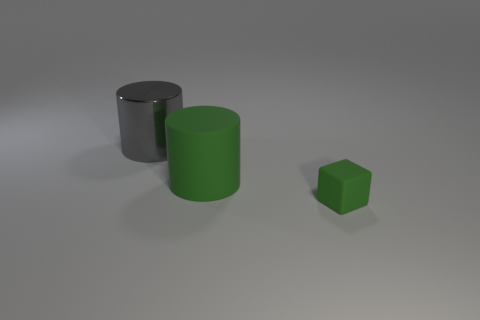Is the tiny rubber object the same color as the rubber cylinder?
Make the answer very short. Yes. There is a cylinder in front of the big gray cylinder; is its size the same as the thing behind the green rubber cylinder?
Your answer should be very brief. Yes. The rubber object that is in front of the large cylinder to the right of the gray cylinder is what color?
Ensure brevity in your answer.  Green. There is a green object that is the same size as the gray cylinder; what is it made of?
Provide a succinct answer. Rubber. How many shiny things are large objects or large gray objects?
Ensure brevity in your answer.  1. What is the color of the thing that is behind the small green cube and in front of the shiny object?
Keep it short and to the point. Green. There is a small green thing; how many large gray cylinders are on the right side of it?
Provide a succinct answer. 0. What is the material of the big green thing?
Your response must be concise. Rubber. The cylinder behind the matte object behind the small matte thing in front of the large green rubber cylinder is what color?
Provide a succinct answer. Gray. How many rubber objects are the same size as the gray metallic object?
Keep it short and to the point. 1. 